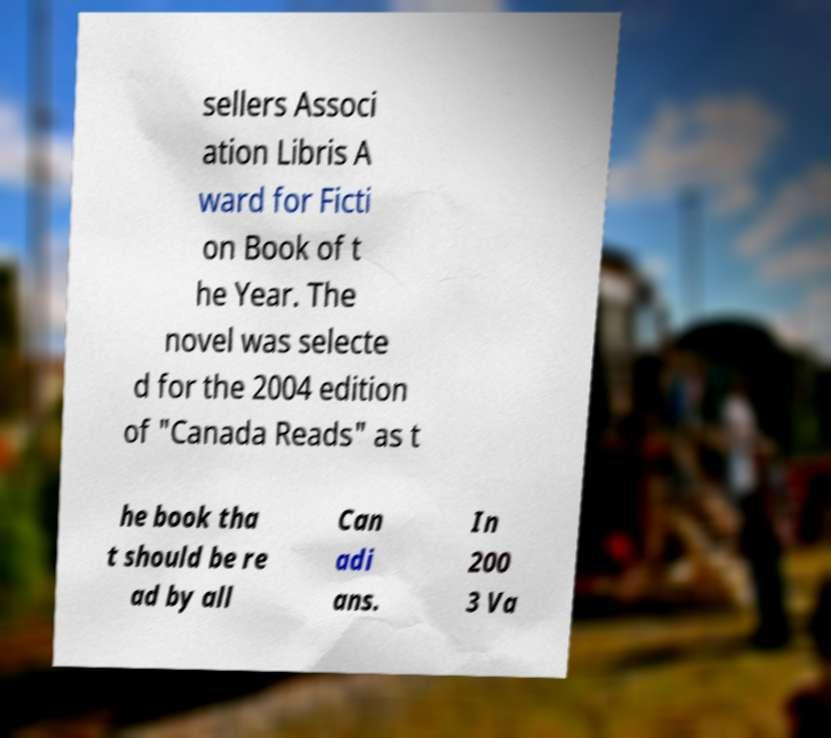What messages or text are displayed in this image? I need them in a readable, typed format. sellers Associ ation Libris A ward for Ficti on Book of t he Year. The novel was selecte d for the 2004 edition of "Canada Reads" as t he book tha t should be re ad by all Can adi ans. In 200 3 Va 